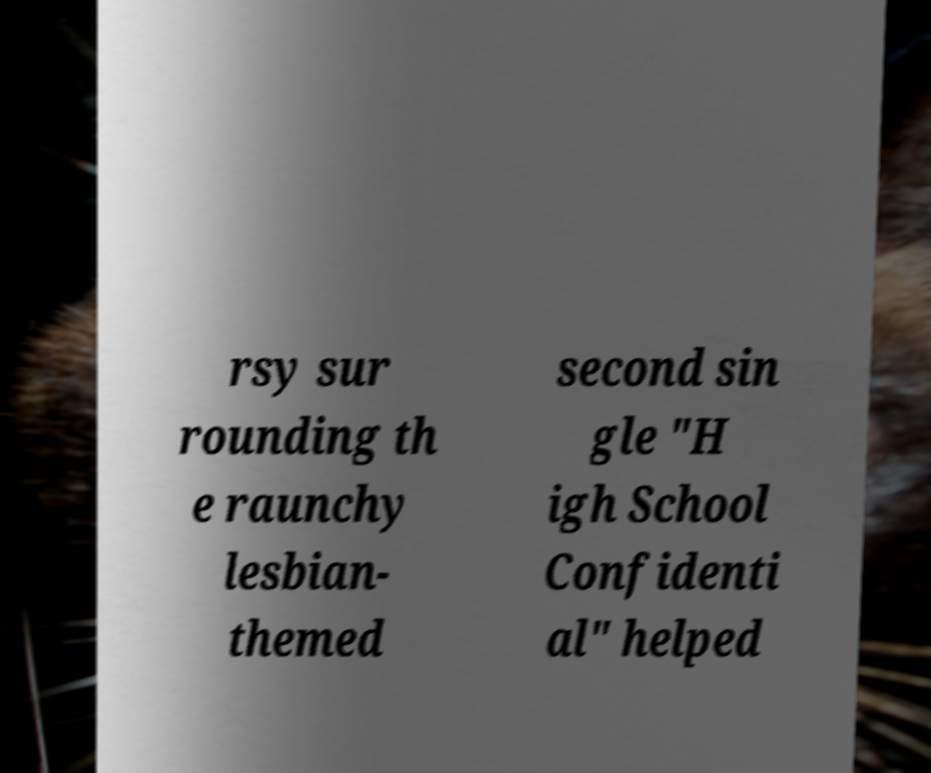Could you extract and type out the text from this image? rsy sur rounding th e raunchy lesbian- themed second sin gle "H igh School Confidenti al" helped 